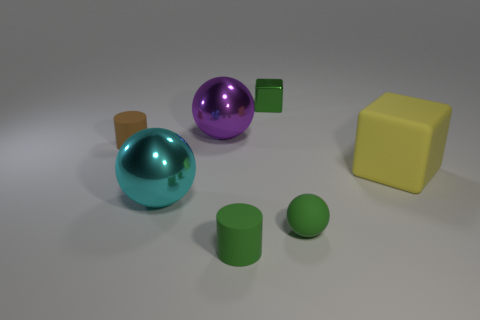Which objects in the image seem to reflect the most light? The objects reflecting the most light in the image are the two spheres, one purple and one teal. Their shiny surfaces suggest they are likely made of a reflective material such as polished metal or coated rubber. 